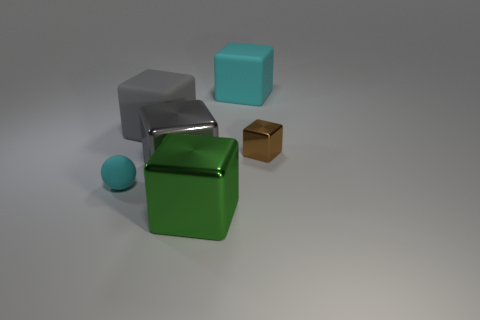How many other rubber blocks are the same size as the gray rubber block?
Make the answer very short. 1. Is the shape of the green thing the same as the tiny rubber thing?
Offer a very short reply. No. The thing that is on the right side of the cube behind the gray matte cube is what color?
Make the answer very short. Brown. There is a object that is both on the left side of the large gray shiny block and in front of the brown thing; how big is it?
Provide a short and direct response. Small. Is there any other thing of the same color as the tiny matte object?
Your response must be concise. Yes. There is a big object that is made of the same material as the big green block; what shape is it?
Ensure brevity in your answer.  Cube. Is the shape of the small matte thing the same as the big metal thing in front of the small cyan ball?
Offer a terse response. No. The tiny object to the right of the big rubber thing that is left of the green metal thing is made of what material?
Offer a very short reply. Metal. Is the number of small matte things that are in front of the small cyan object the same as the number of purple metal objects?
Offer a very short reply. Yes. There is a big metallic block that is behind the tiny cyan object; is its color the same as the large rubber thing in front of the large cyan thing?
Your answer should be compact. Yes. 